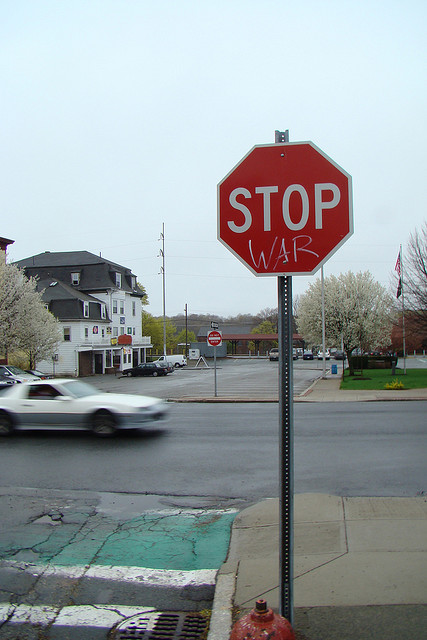What might the reactions be from people seeing this modified stop sign? Reactions to the modified stop sign likely vary widely. Some residents might feel a strong sense of pride or agreement with its anti-war message, appreciating this bold expression of political stance. Others might find it provocative or inappropriate, feeling that public signage should not be used for political statements. Nonetheless, this sign definitely sparks conversation and reflection, causing people to pause – literally and metaphorically – and consider the issues of war and peace. 